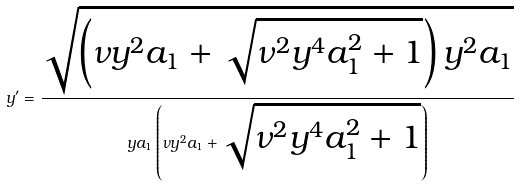<formula> <loc_0><loc_0><loc_500><loc_500>y ^ { \prime } = \frac { \sqrt { \left ( \nu y ^ { 2 } a _ { 1 } + \sqrt { \nu ^ { 2 } y ^ { 4 } a _ { 1 } ^ { 2 } + 1 } \right ) y ^ { 2 } a _ { 1 } } } { y a _ { 1 } \left ( \nu y ^ { 2 } a _ { 1 } + \sqrt { \nu ^ { 2 } y ^ { 4 } a _ { 1 } ^ { 2 } + 1 } \right ) }</formula> 